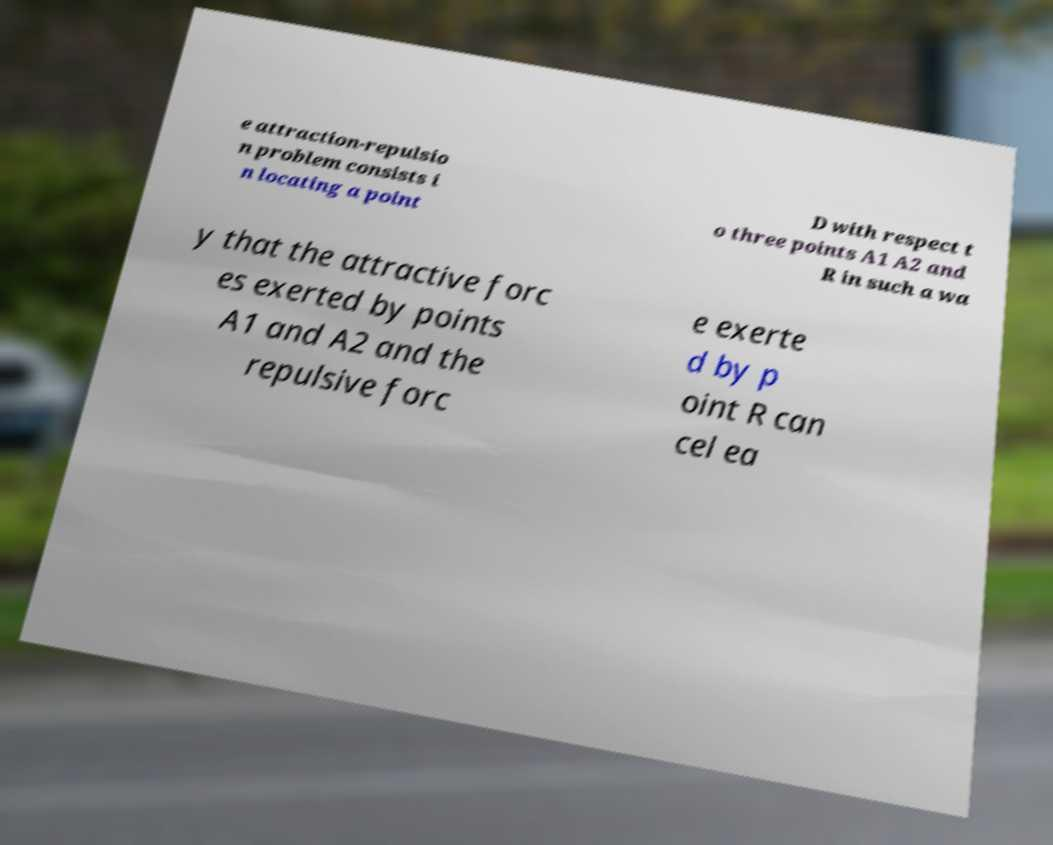Please identify and transcribe the text found in this image. e attraction-repulsio n problem consists i n locating a point D with respect t o three points A1 A2 and R in such a wa y that the attractive forc es exerted by points A1 and A2 and the repulsive forc e exerte d by p oint R can cel ea 